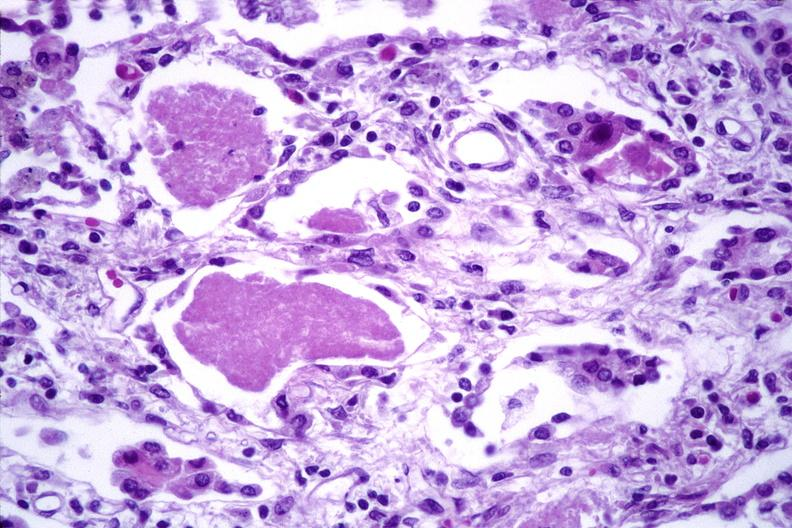s hand present?
Answer the question using a single word or phrase. No 